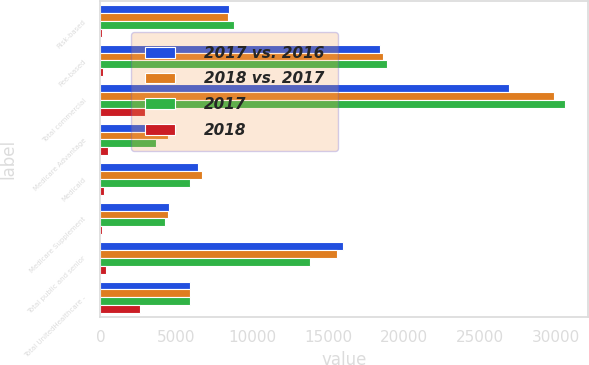<chart> <loc_0><loc_0><loc_500><loc_500><stacked_bar_chart><ecel><fcel>Risk-based<fcel>Fee-based<fcel>Total commercial<fcel>Medicare Advantage<fcel>Medicaid<fcel>Medicare Supplement<fcel>Total public and senior<fcel>Total UnitedHealthcare -<nl><fcel>2017 vs. 2016<fcel>8495<fcel>18420<fcel>26915<fcel>4945<fcel>6450<fcel>4545<fcel>15940<fcel>5890<nl><fcel>2018 vs. 2017<fcel>8420<fcel>18595<fcel>29865<fcel>4430<fcel>6705<fcel>4445<fcel>15580<fcel>5890<nl><fcel>2017<fcel>8820<fcel>18900<fcel>30580<fcel>3630<fcel>5890<fcel>4265<fcel>13785<fcel>5890<nl><fcel>2018<fcel>75<fcel>175<fcel>2950<fcel>515<fcel>255<fcel>100<fcel>360<fcel>2590<nl></chart> 